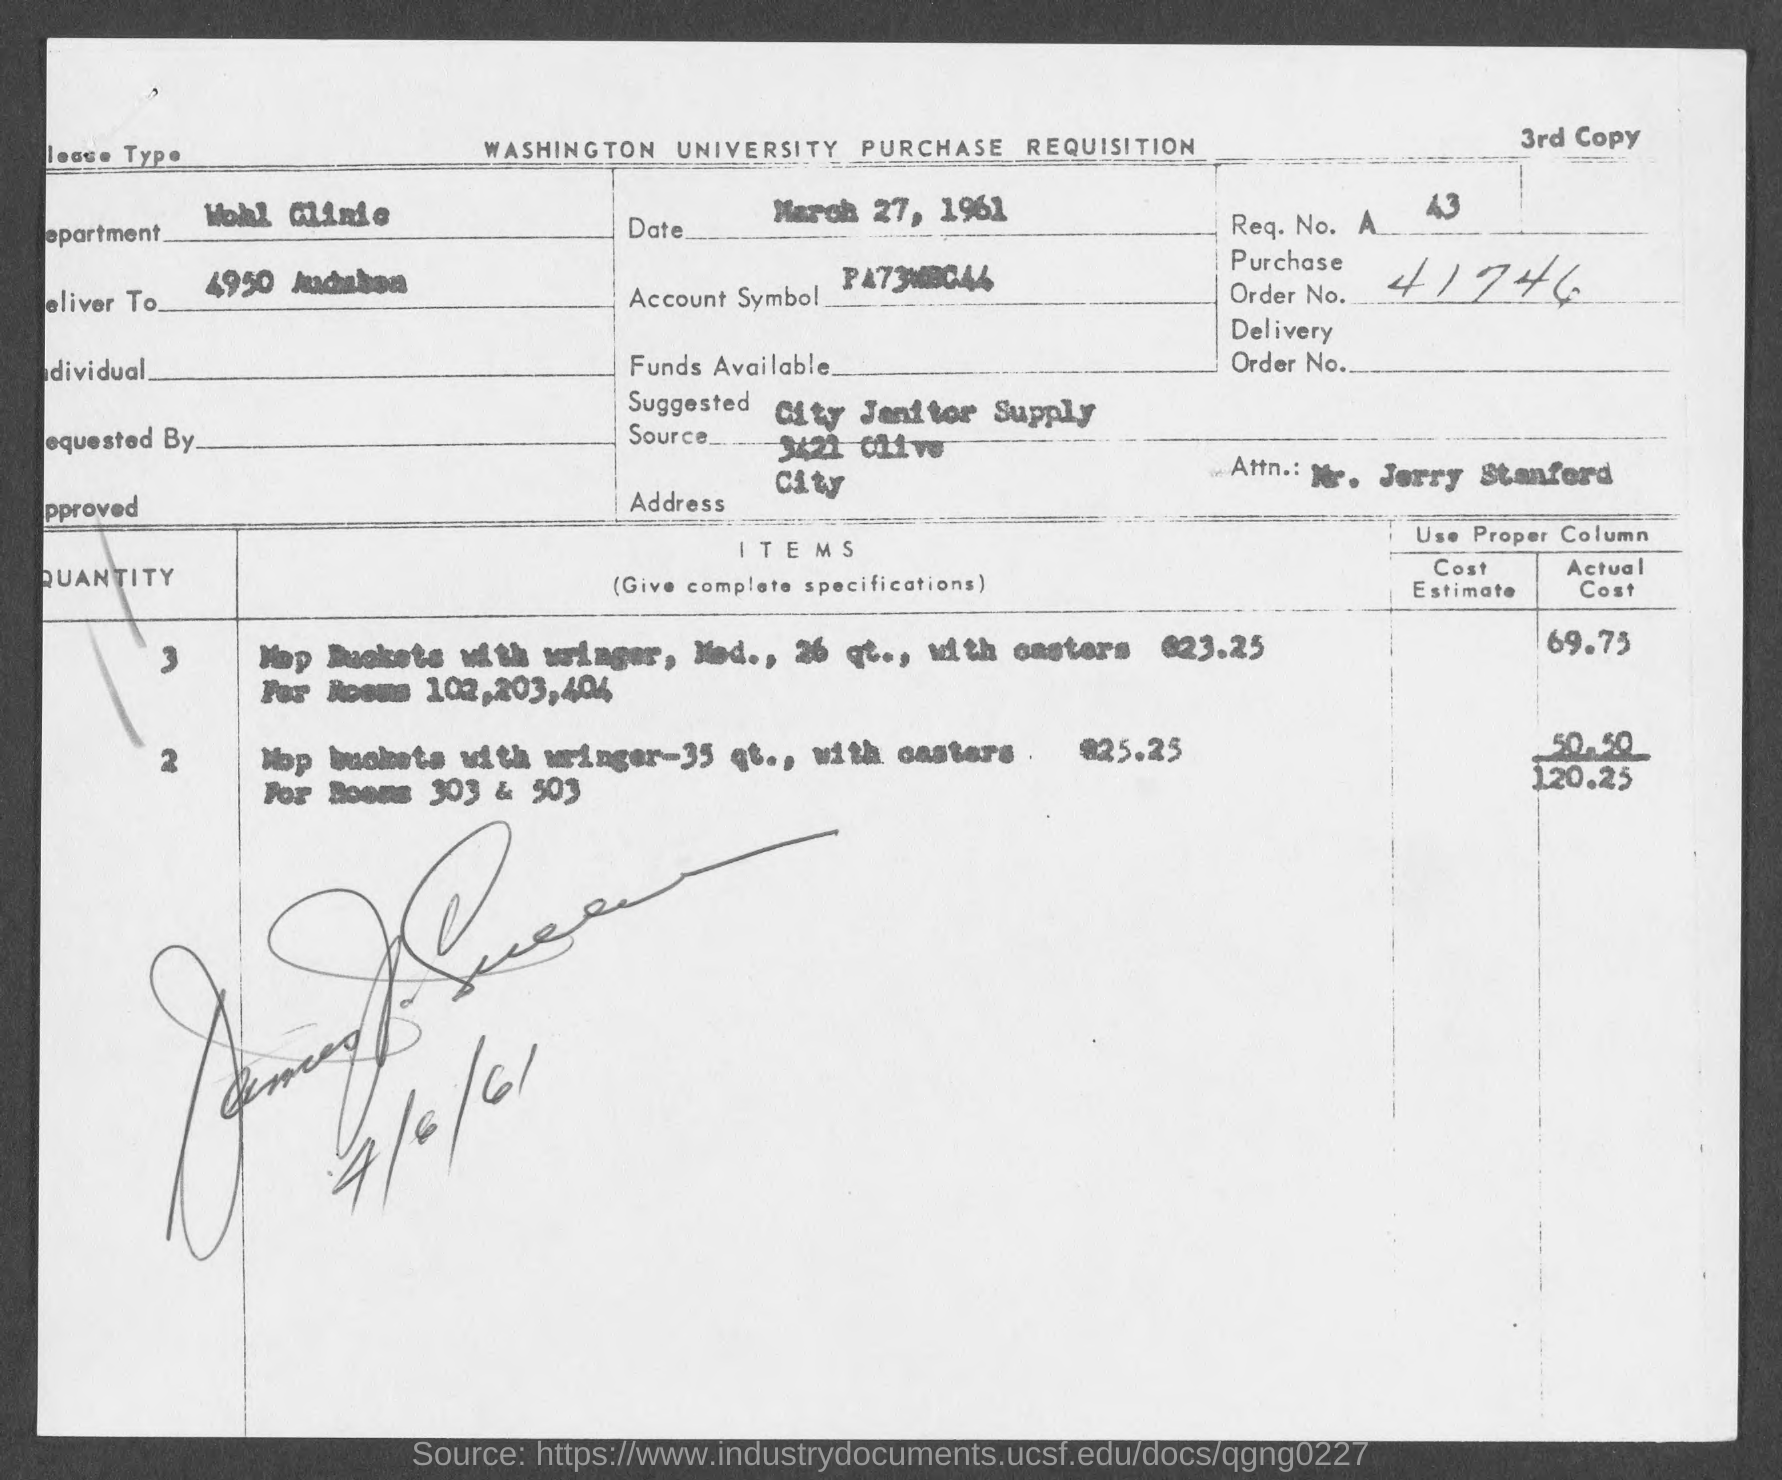What is the document about?
Your answer should be very brief. WASHINGTON UNIVERSITY PURCHASE REQUISITION. What is the date given?
Provide a succinct answer. March 27, 1961. What is the purchase order no.?
Your response must be concise. 41746. 